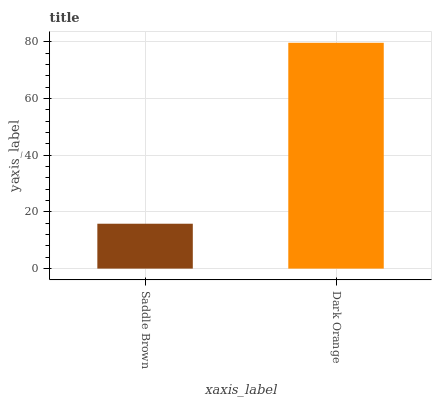Is Saddle Brown the minimum?
Answer yes or no. Yes. Is Dark Orange the maximum?
Answer yes or no. Yes. Is Dark Orange the minimum?
Answer yes or no. No. Is Dark Orange greater than Saddle Brown?
Answer yes or no. Yes. Is Saddle Brown less than Dark Orange?
Answer yes or no. Yes. Is Saddle Brown greater than Dark Orange?
Answer yes or no. No. Is Dark Orange less than Saddle Brown?
Answer yes or no. No. Is Dark Orange the high median?
Answer yes or no. Yes. Is Saddle Brown the low median?
Answer yes or no. Yes. Is Saddle Brown the high median?
Answer yes or no. No. Is Dark Orange the low median?
Answer yes or no. No. 